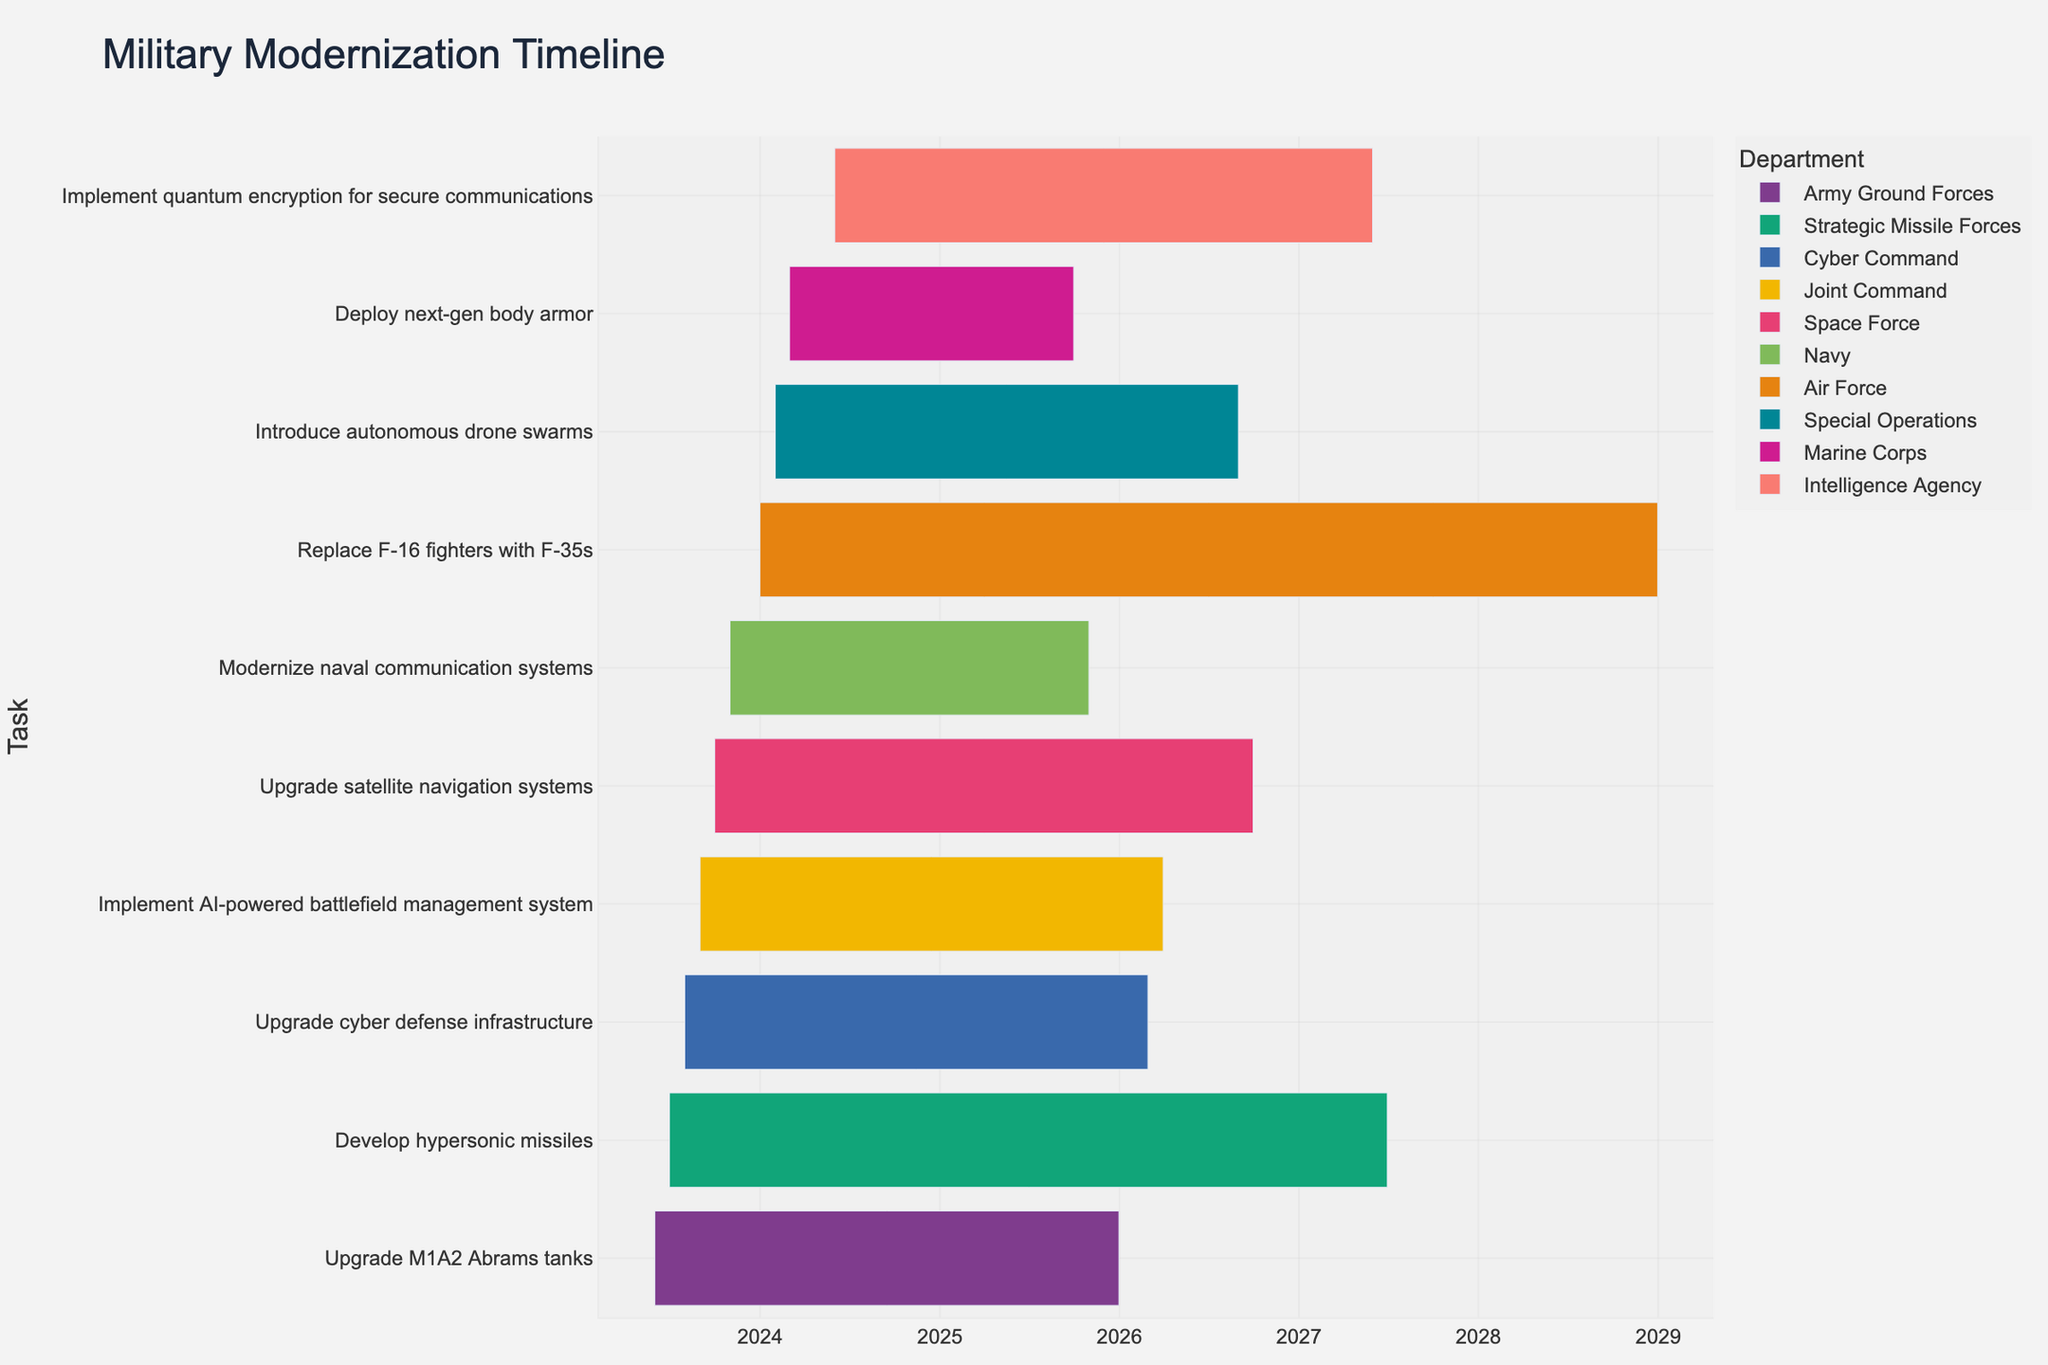Which task takes the longest duration? By calculating the duration for each task, we find that the "Replace F-16 fighters with F-35s" task takes from 2024-01-01 to 2028-12-31, which is almost 5 years.
Answer: Replace F-16 fighters with F-35s Which department is responsible for the most tasks? By counting the tasks for each department, we see that all departments have one task each, so no department has more tasks than another.
Answer: Each department has 1 task Which task will be completed earliest? By looking at the end dates for all tasks, the "Modernize naval communication systems" task ends the earliest on 2025-10-31.
Answer: Modernize naval communication systems Among the tasks "Upgrade M1A2 Abrams tanks" and "Deploy next-gen body armor," which one starts first? "Upgrade M1A2 Abrams tanks" starts on 2023-06-01, while "Deploy next-gen body armor" starts on 2024-03-01. Therefore, "Upgrade M1A2 Abrams tanks" starts first.
Answer: Upgrade M1A2 Abrams tanks How many tasks involve implementing new technology such as AI, quantum encryption, or autonomous drones? The tasks "Implement AI-powered battlefield management system," "Implement quantum encryption for secure communications," and "Introduce autonomous drone swarms" involve new technology. That's three tasks total.
Answer: 3 tasks Which tasks are being handled by Joint Command? By looking at the color and legend, we see that "Implement AI-powered battlefield management system" is the task handled by Joint Command.
Answer: Implement AI-powered battlefield management system Which task overlaps the most with the "Upgrade M1A2 Abrams tanks" task? "Upgrade M1A2 Abrams tanks" runs from 2023-06-01 to 2025-12-31. We need to check which other tasks' time period overlaps the most. "Implement AI-powered battlefield management system," "Develop hypersonic missiles," and "Upgrade cyber defense infrastructure" have significant overlaps. "Develop hypersonic missiles" overlaps from 2023-07-01 to 2025-12-31, covering almost the entire duration.
Answer: Develop hypersonic missiles Is there any department whose tasks start in 2024? By examining the start dates of tasks, several tasks start in 2024 under departments like Air Force, Marine Corps, Intelligence Agency, and Special Operations.
Answer: Yes Which task has the shortest duration? By checking the durations calculated for all tasks, "Deploy next-gen body armor" has the shortest duration from 2024-03-01 to 2025-09-30, which is 1 year and 6 months.
Answer: Deploy next-gen body armor Are there any tasks that finish in 2027? By examining the end dates, "Develop hypersonic missiles" and "Implement quantum encryption for secure communications" both end in 2027.
Answer: Yes 